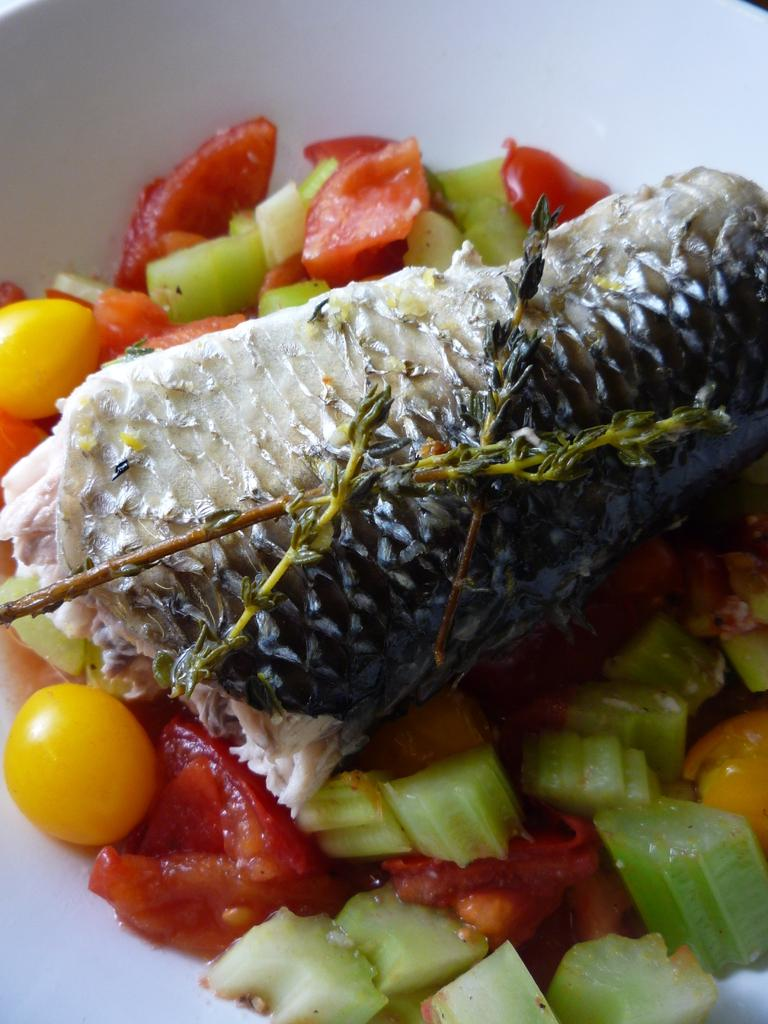What type of food items can be seen in the image? There are vegetable food items in the image. What other type of food item is present in the image? There is meat on a plate in the image. What is the purpose of the whip in the image? There is no whip present in the image. How is the spade used in the image? There is no spade present in the image. 